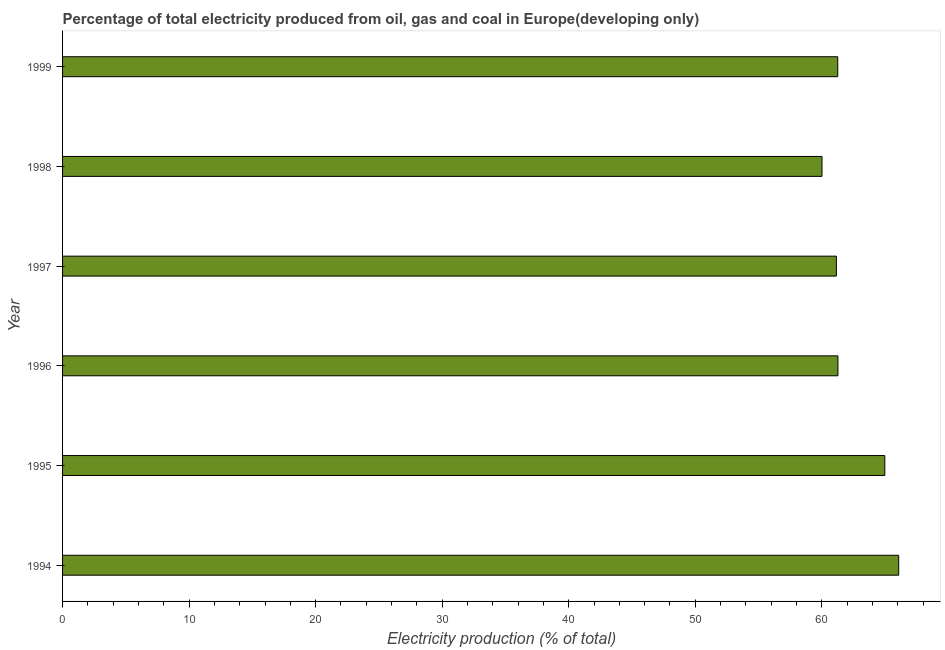Does the graph contain grids?
Your response must be concise. No. What is the title of the graph?
Offer a very short reply. Percentage of total electricity produced from oil, gas and coal in Europe(developing only). What is the label or title of the X-axis?
Provide a short and direct response. Electricity production (% of total). What is the electricity production in 1997?
Provide a short and direct response. 61.15. Across all years, what is the maximum electricity production?
Make the answer very short. 66.08. Across all years, what is the minimum electricity production?
Your response must be concise. 60.01. In which year was the electricity production minimum?
Give a very brief answer. 1998. What is the sum of the electricity production?
Your answer should be very brief. 374.76. What is the difference between the electricity production in 1994 and 1997?
Provide a short and direct response. 4.92. What is the average electricity production per year?
Provide a succinct answer. 62.46. What is the median electricity production?
Ensure brevity in your answer.  61.27. Do a majority of the years between 1995 and 1996 (inclusive) have electricity production greater than 20 %?
Ensure brevity in your answer.  Yes. What is the ratio of the electricity production in 1995 to that in 1997?
Offer a very short reply. 1.06. Is the difference between the electricity production in 1994 and 1999 greater than the difference between any two years?
Offer a very short reply. No. What is the difference between the highest and the second highest electricity production?
Give a very brief answer. 1.1. What is the difference between the highest and the lowest electricity production?
Provide a short and direct response. 6.06. What is the difference between two consecutive major ticks on the X-axis?
Ensure brevity in your answer.  10. What is the Electricity production (% of total) in 1994?
Provide a short and direct response. 66.08. What is the Electricity production (% of total) of 1995?
Your answer should be compact. 64.98. What is the Electricity production (% of total) in 1996?
Make the answer very short. 61.28. What is the Electricity production (% of total) in 1997?
Offer a very short reply. 61.15. What is the Electricity production (% of total) of 1998?
Your answer should be very brief. 60.01. What is the Electricity production (% of total) in 1999?
Keep it short and to the point. 61.26. What is the difference between the Electricity production (% of total) in 1994 and 1995?
Provide a short and direct response. 1.1. What is the difference between the Electricity production (% of total) in 1994 and 1996?
Offer a terse response. 4.8. What is the difference between the Electricity production (% of total) in 1994 and 1997?
Ensure brevity in your answer.  4.92. What is the difference between the Electricity production (% of total) in 1994 and 1998?
Provide a short and direct response. 6.06. What is the difference between the Electricity production (% of total) in 1994 and 1999?
Your answer should be very brief. 4.82. What is the difference between the Electricity production (% of total) in 1995 and 1996?
Keep it short and to the point. 3.71. What is the difference between the Electricity production (% of total) in 1995 and 1997?
Provide a short and direct response. 3.83. What is the difference between the Electricity production (% of total) in 1995 and 1998?
Offer a terse response. 4.97. What is the difference between the Electricity production (% of total) in 1995 and 1999?
Offer a very short reply. 3.72. What is the difference between the Electricity production (% of total) in 1996 and 1997?
Give a very brief answer. 0.12. What is the difference between the Electricity production (% of total) in 1996 and 1998?
Your response must be concise. 1.26. What is the difference between the Electricity production (% of total) in 1996 and 1999?
Give a very brief answer. 0.01. What is the difference between the Electricity production (% of total) in 1997 and 1998?
Offer a very short reply. 1.14. What is the difference between the Electricity production (% of total) in 1997 and 1999?
Ensure brevity in your answer.  -0.11. What is the difference between the Electricity production (% of total) in 1998 and 1999?
Your answer should be compact. -1.25. What is the ratio of the Electricity production (% of total) in 1994 to that in 1995?
Your response must be concise. 1.02. What is the ratio of the Electricity production (% of total) in 1994 to that in 1996?
Your response must be concise. 1.08. What is the ratio of the Electricity production (% of total) in 1994 to that in 1997?
Keep it short and to the point. 1.08. What is the ratio of the Electricity production (% of total) in 1994 to that in 1998?
Provide a succinct answer. 1.1. What is the ratio of the Electricity production (% of total) in 1994 to that in 1999?
Ensure brevity in your answer.  1.08. What is the ratio of the Electricity production (% of total) in 1995 to that in 1996?
Ensure brevity in your answer.  1.06. What is the ratio of the Electricity production (% of total) in 1995 to that in 1997?
Ensure brevity in your answer.  1.06. What is the ratio of the Electricity production (% of total) in 1995 to that in 1998?
Offer a terse response. 1.08. What is the ratio of the Electricity production (% of total) in 1995 to that in 1999?
Provide a succinct answer. 1.06. What is the ratio of the Electricity production (% of total) in 1996 to that in 1997?
Keep it short and to the point. 1. What is the ratio of the Electricity production (% of total) in 1996 to that in 1998?
Offer a very short reply. 1.02. What is the ratio of the Electricity production (% of total) in 1997 to that in 1998?
Ensure brevity in your answer.  1.02. What is the ratio of the Electricity production (% of total) in 1998 to that in 1999?
Offer a terse response. 0.98. 